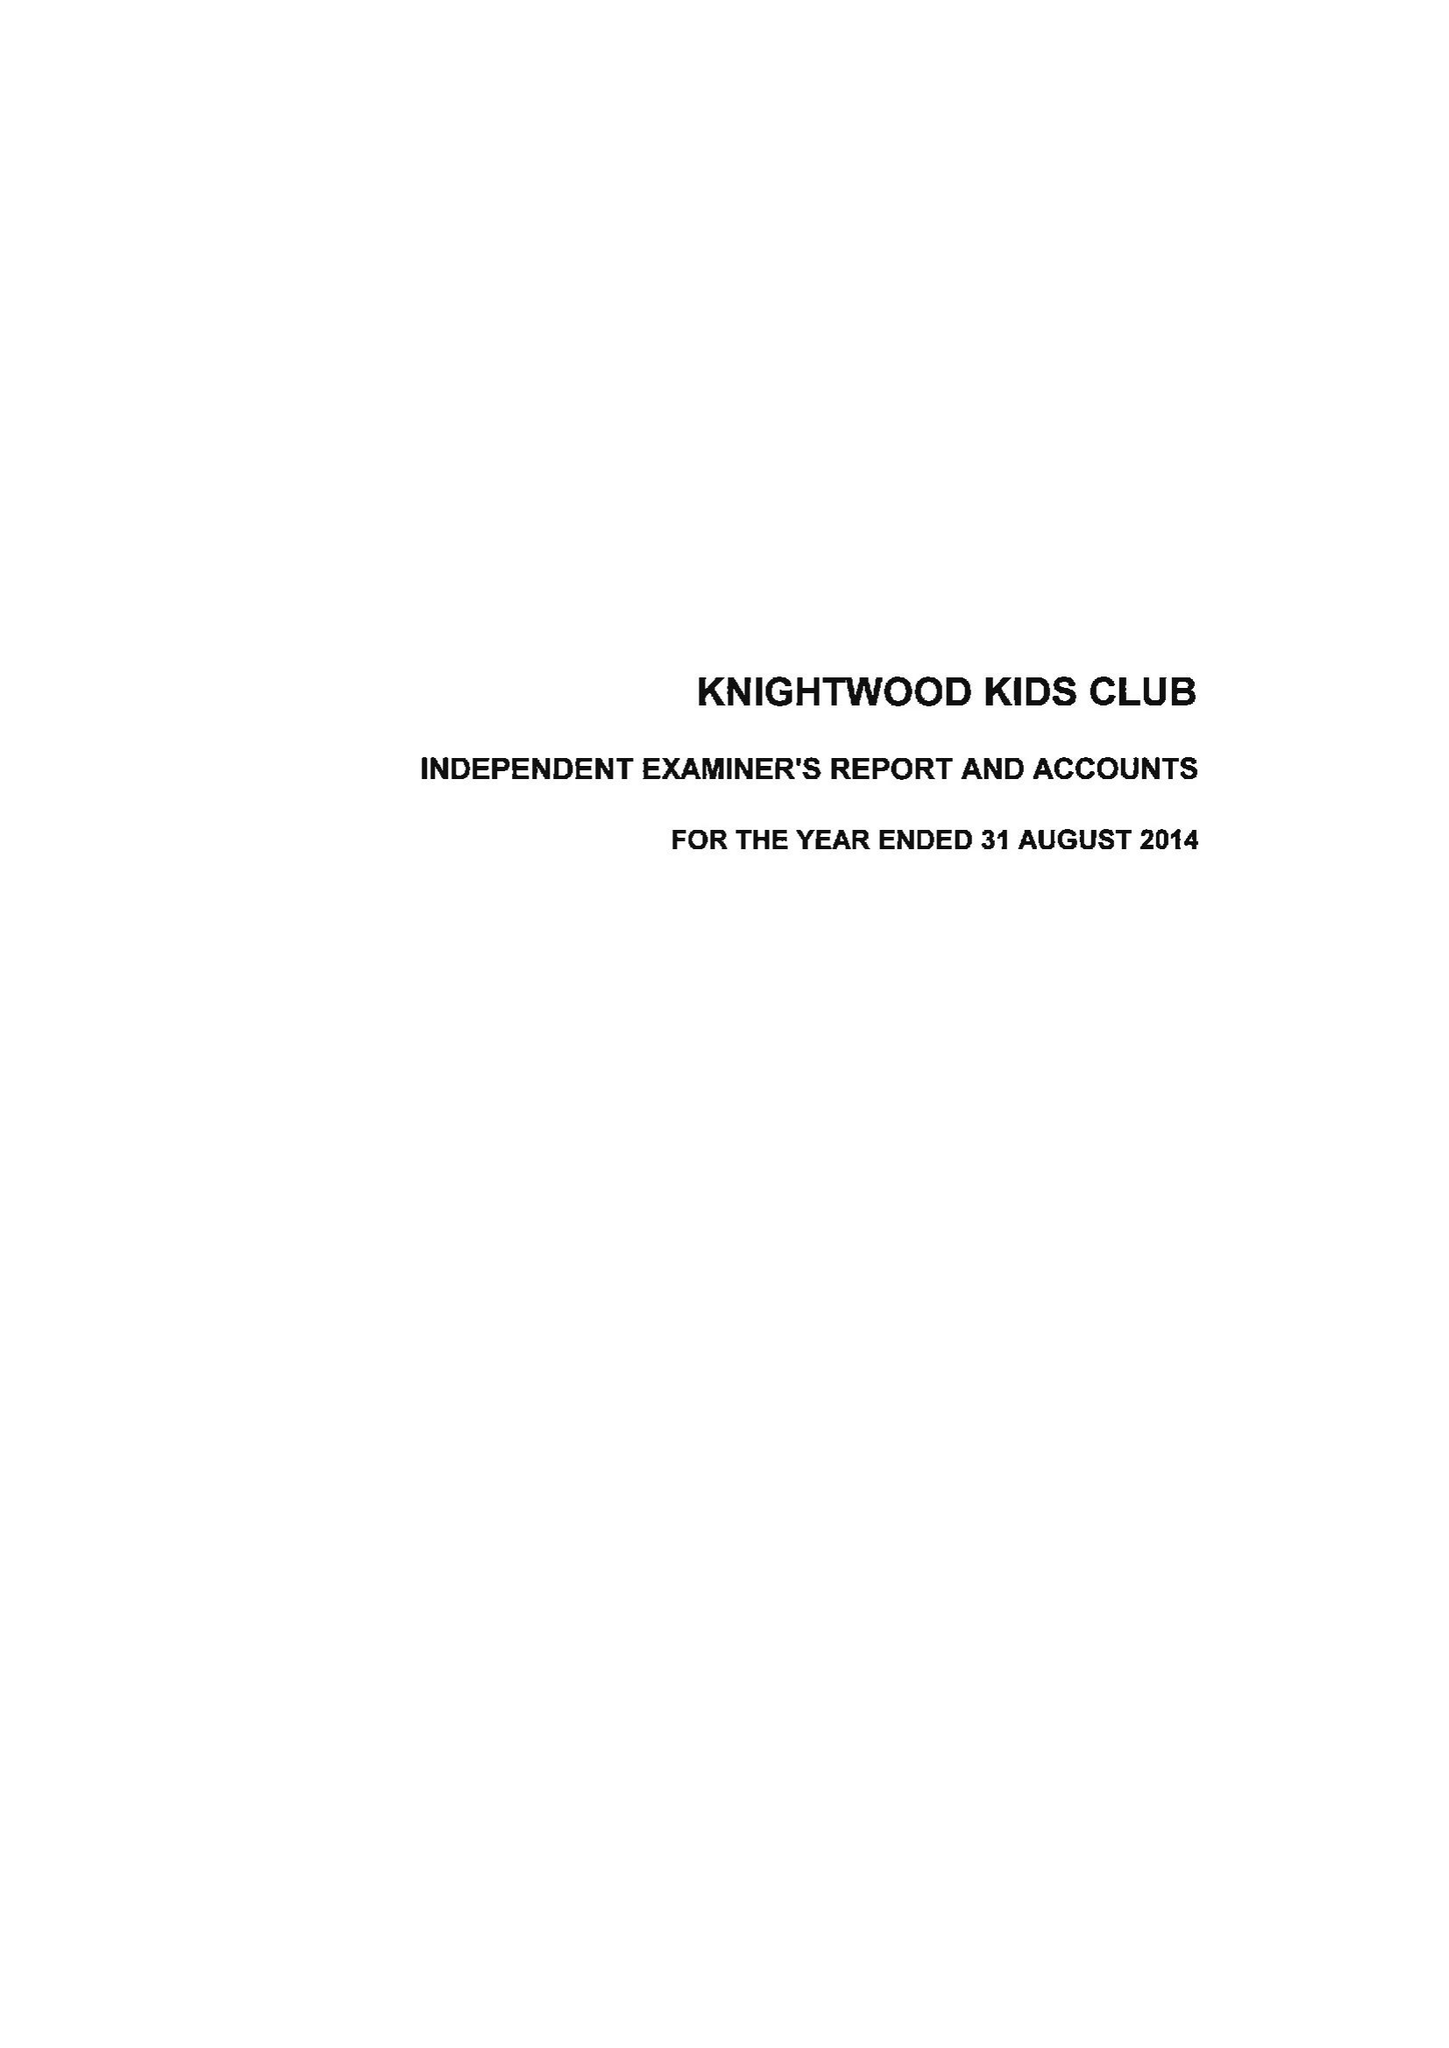What is the value for the charity_name?
Answer the question using a single word or phrase. Knightwood Kids Club 